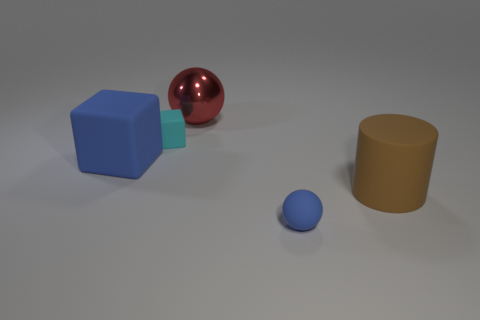What is the material of the brown cylinder?
Keep it short and to the point. Rubber. What shape is the tiny blue object that is made of the same material as the large cylinder?
Make the answer very short. Sphere. What number of other objects are there of the same shape as the big brown rubber thing?
Your answer should be compact. 0. What number of blue rubber things are in front of the brown cylinder?
Provide a succinct answer. 1. There is a object that is behind the cyan object; is its size the same as the brown rubber cylinder in front of the shiny sphere?
Provide a succinct answer. Yes. What number of other things are the same size as the red sphere?
Your response must be concise. 2. What is the cube behind the big rubber object left of the rubber cube behind the large matte block made of?
Your answer should be very brief. Rubber. Do the red object and the sphere that is in front of the cylinder have the same size?
Provide a succinct answer. No. There is a matte thing that is both behind the big brown matte cylinder and to the right of the large blue object; what size is it?
Make the answer very short. Small. Is there a small matte object of the same color as the shiny sphere?
Provide a short and direct response. No. 